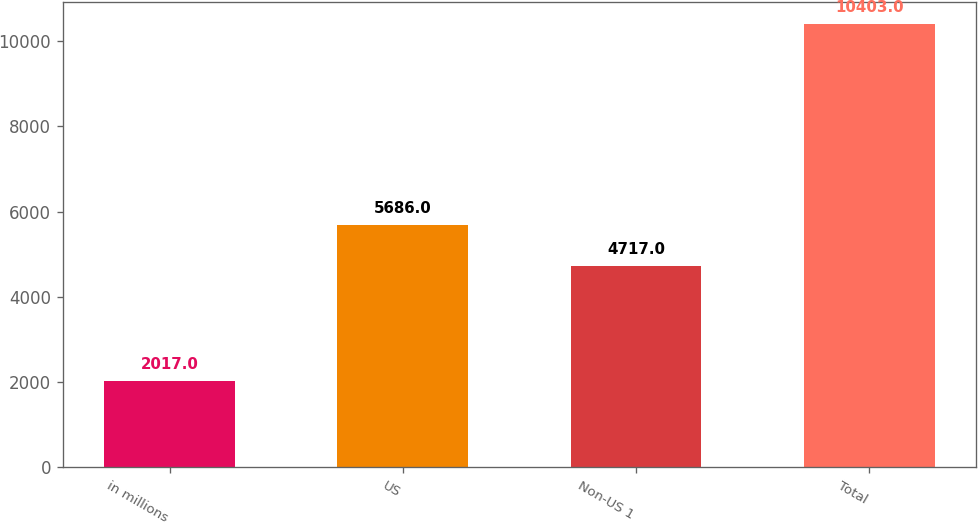<chart> <loc_0><loc_0><loc_500><loc_500><bar_chart><fcel>in millions<fcel>US<fcel>Non-US 1<fcel>Total<nl><fcel>2017<fcel>5686<fcel>4717<fcel>10403<nl></chart> 